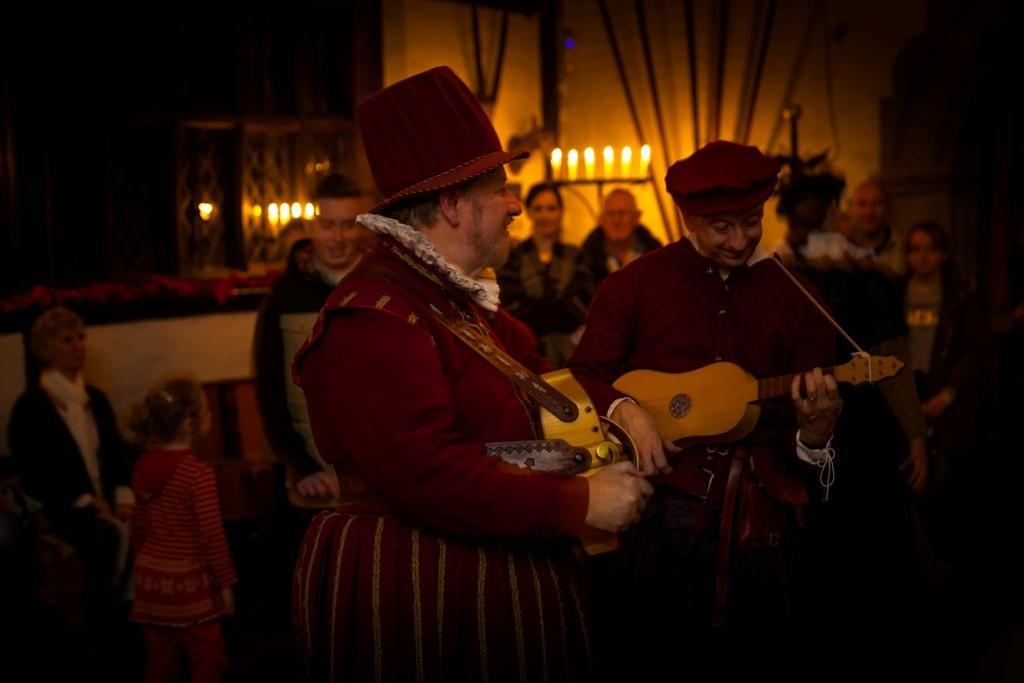Describe this image in one or two sentences. In this image there are of people. In the front there are two people standing and playing musical instruments. At the back there are candles. 